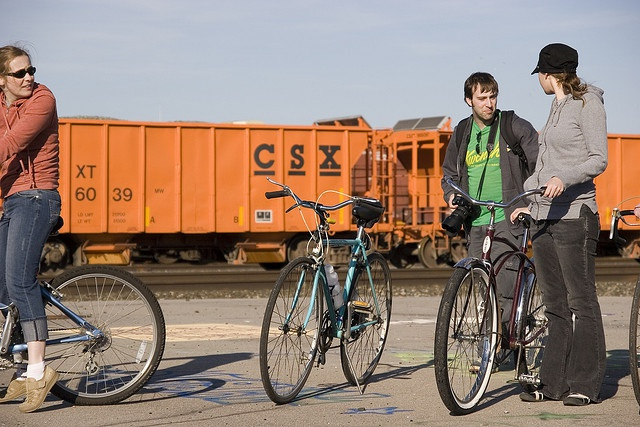Describe the objects in this image and their specific colors. I can see train in darkgray, salmon, orange, and brown tones, people in darkgray, black, and gray tones, bicycle in darkgray, black, and gray tones, bicycle in darkgray, gray, and black tones, and people in darkgray, gray, black, brown, and salmon tones in this image. 